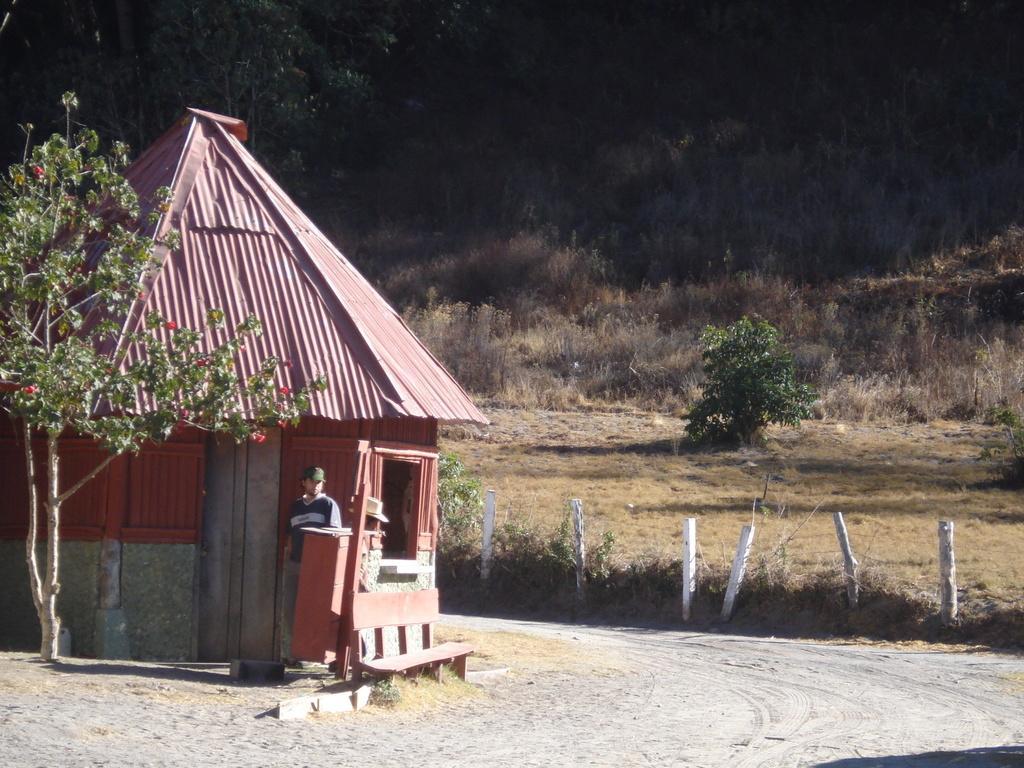Describe this image in one or two sentences. In this image I can see the person standing. In the background I can see the shed and I can also see few trees in green color and few flowers in red color. 